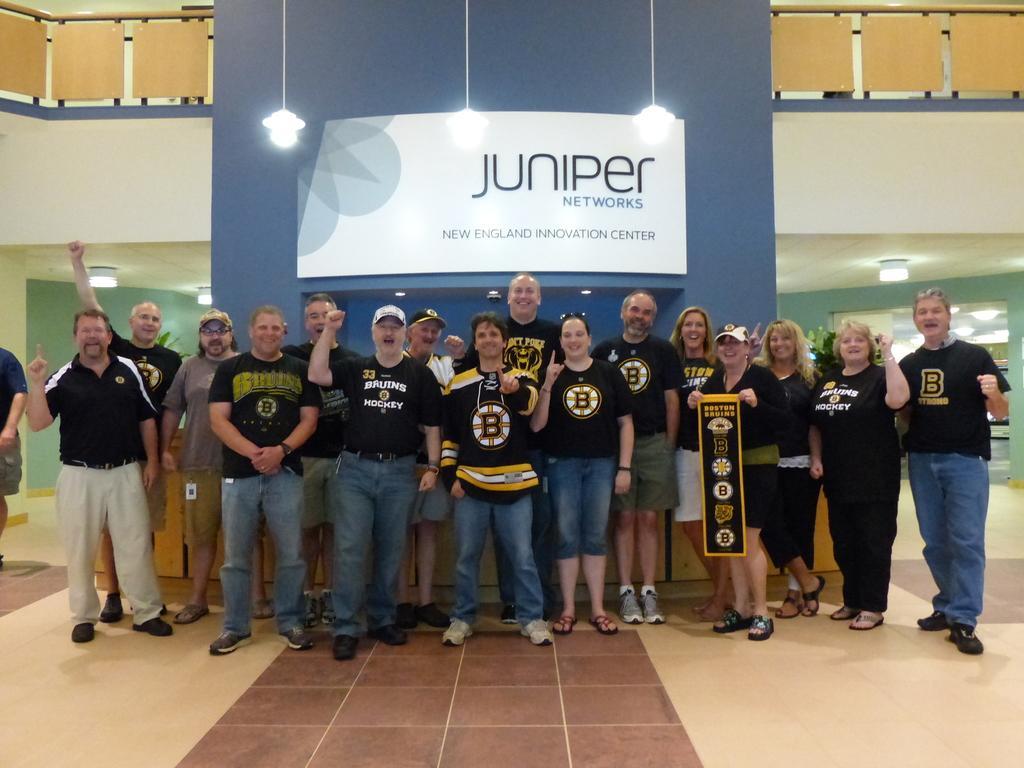How would you summarize this image in a sentence or two? In this image there are a group of people standing, and one person is holding a board. And in the background there is a board, lights, wall, railing, planter, table and at the bottom there is floor. 